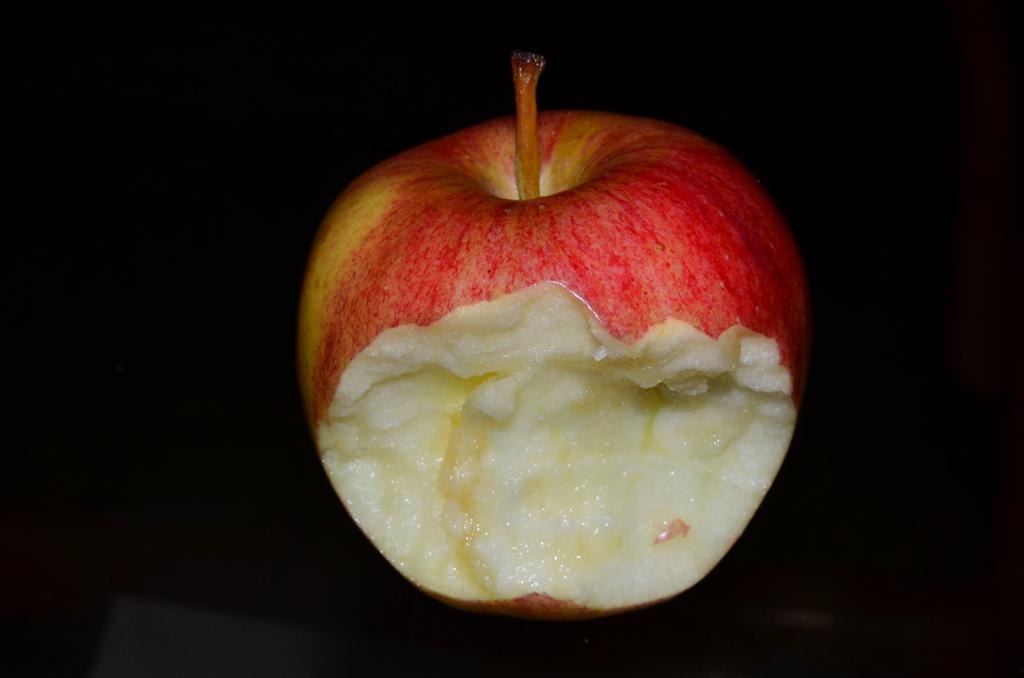In one or two sentences, can you explain what this image depicts? In the center of the image there is a half eaten apple. 